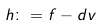Convert formula to latex. <formula><loc_0><loc_0><loc_500><loc_500>h \colon = f - d v</formula> 